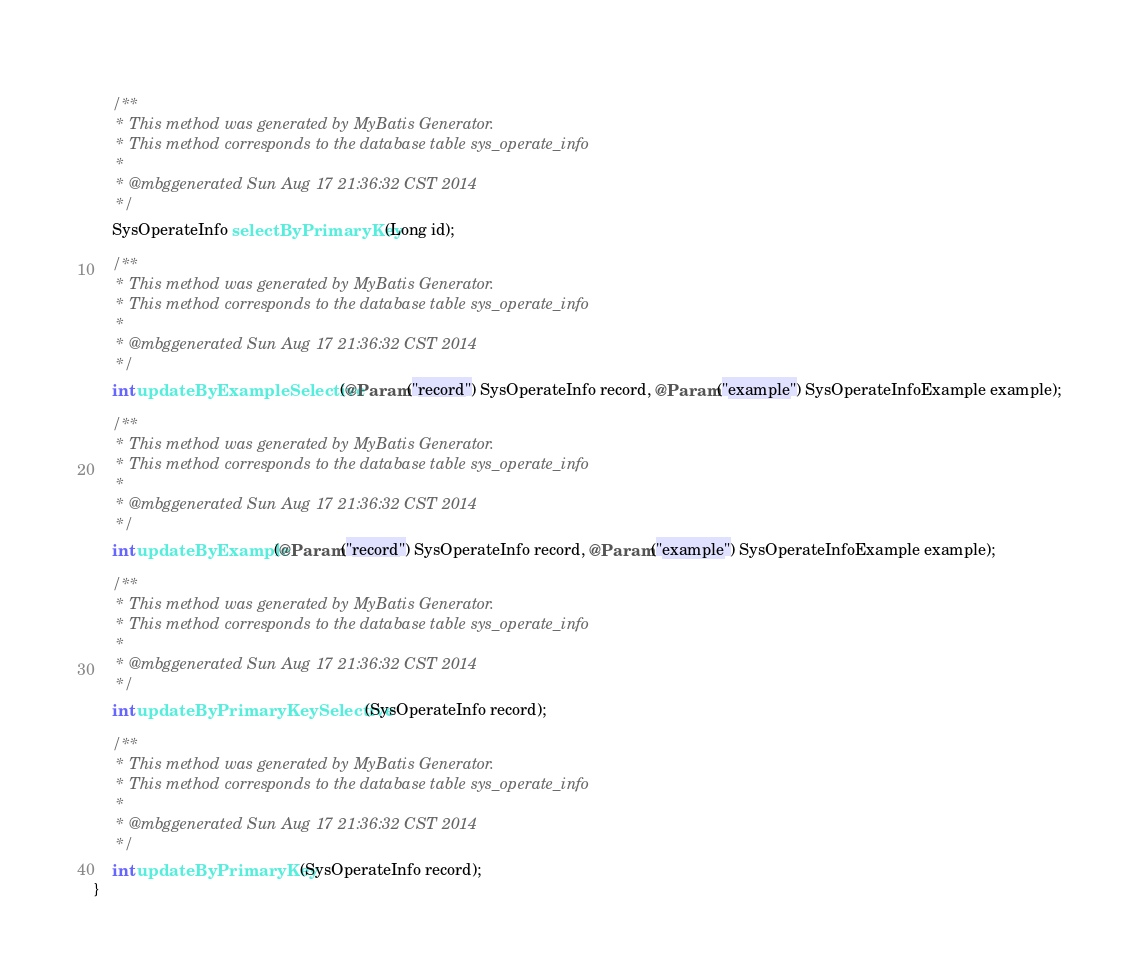Convert code to text. <code><loc_0><loc_0><loc_500><loc_500><_Java_>    
    /**
     * This method was generated by MyBatis Generator.
     * This method corresponds to the database table sys_operate_info
     *
     * @mbggenerated Sun Aug 17 21:36:32 CST 2014
     */
    SysOperateInfo selectByPrimaryKey(Long id);

    /**
     * This method was generated by MyBatis Generator.
     * This method corresponds to the database table sys_operate_info
     *
     * @mbggenerated Sun Aug 17 21:36:32 CST 2014
     */
    int updateByExampleSelective(@Param("record") SysOperateInfo record, @Param("example") SysOperateInfoExample example);

    /**
     * This method was generated by MyBatis Generator.
     * This method corresponds to the database table sys_operate_info
     *
     * @mbggenerated Sun Aug 17 21:36:32 CST 2014
     */
    int updateByExample(@Param("record") SysOperateInfo record, @Param("example") SysOperateInfoExample example);

    /**
     * This method was generated by MyBatis Generator.
     * This method corresponds to the database table sys_operate_info
     *
     * @mbggenerated Sun Aug 17 21:36:32 CST 2014
     */
    int updateByPrimaryKeySelective(SysOperateInfo record);

    /**
     * This method was generated by MyBatis Generator.
     * This method corresponds to the database table sys_operate_info
     *
     * @mbggenerated Sun Aug 17 21:36:32 CST 2014
     */
    int updateByPrimaryKey(SysOperateInfo record);
}
</code> 